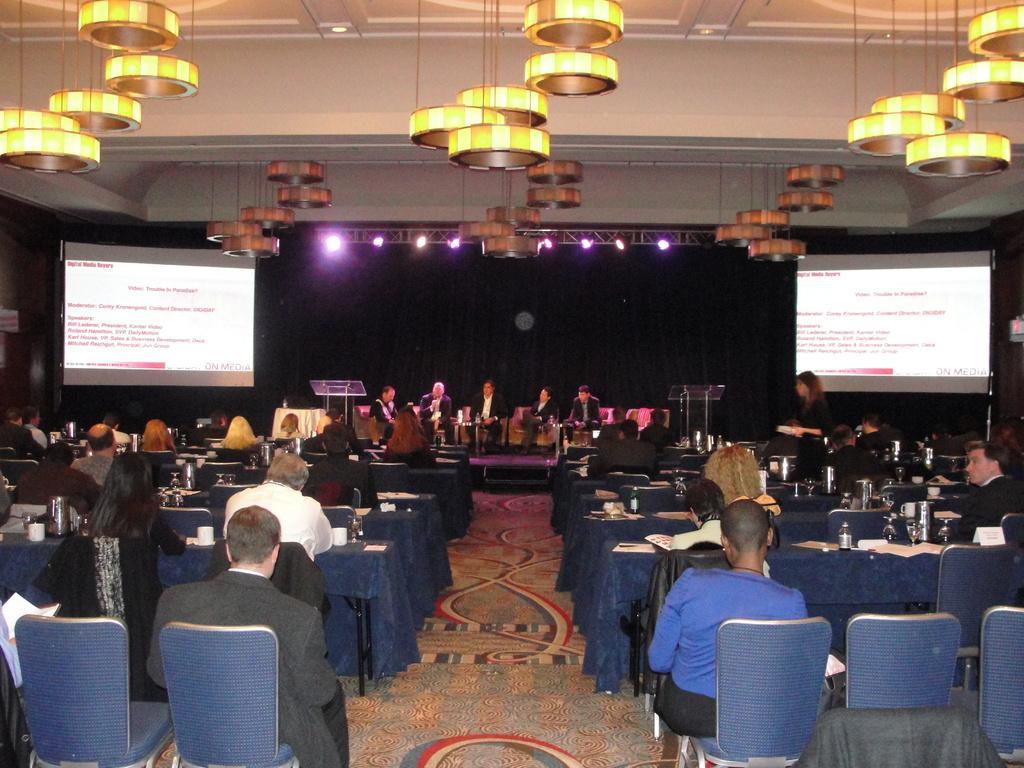In one or two sentences, can you explain what this image depicts? In this image I can see few chairs which are blue in color and few persons sitting on chairs in front of desks. On the desks I can see few bottles, few glasses and few papers. In the background I can see the stage, few persons sitting on couches, few lights to the metal rods, the ceiling, few lights to the ceiling, two podiums and two screens. 